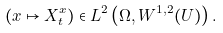<formula> <loc_0><loc_0><loc_500><loc_500>( x \mapsto X _ { t } ^ { x } ) \in L ^ { 2 } \left ( \Omega , W ^ { 1 , 2 } ( U ) \right ) .</formula> 